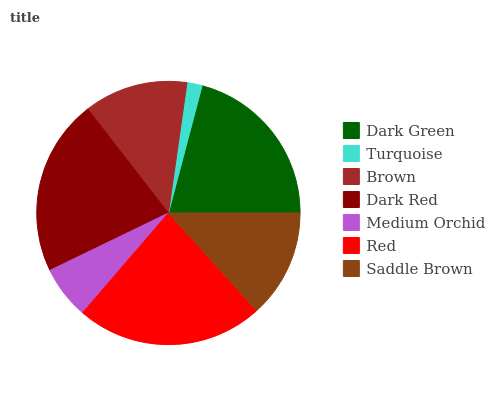Is Turquoise the minimum?
Answer yes or no. Yes. Is Red the maximum?
Answer yes or no. Yes. Is Brown the minimum?
Answer yes or no. No. Is Brown the maximum?
Answer yes or no. No. Is Brown greater than Turquoise?
Answer yes or no. Yes. Is Turquoise less than Brown?
Answer yes or no. Yes. Is Turquoise greater than Brown?
Answer yes or no. No. Is Brown less than Turquoise?
Answer yes or no. No. Is Saddle Brown the high median?
Answer yes or no. Yes. Is Saddle Brown the low median?
Answer yes or no. Yes. Is Dark Green the high median?
Answer yes or no. No. Is Dark Green the low median?
Answer yes or no. No. 